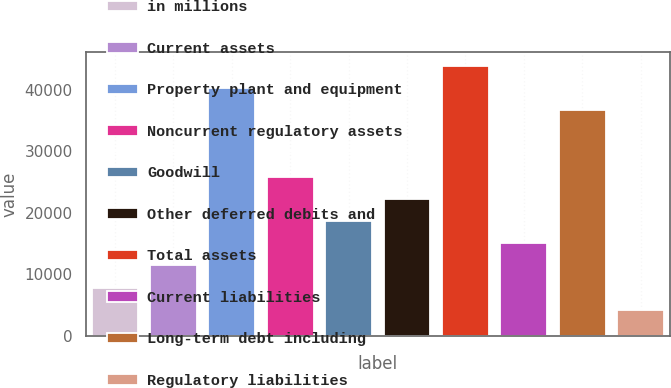Convert chart. <chart><loc_0><loc_0><loc_500><loc_500><bar_chart><fcel>in millions<fcel>Current assets<fcel>Property plant and equipment<fcel>Noncurrent regulatory assets<fcel>Goodwill<fcel>Other deferred debits and<fcel>Total assets<fcel>Current liabilities<fcel>Long-term debt including<fcel>Regulatory liabilities<nl><fcel>7838.8<fcel>11443.2<fcel>40278.4<fcel>25860.8<fcel>18652<fcel>22256.4<fcel>43882.8<fcel>15047.6<fcel>36674<fcel>4234.4<nl></chart> 